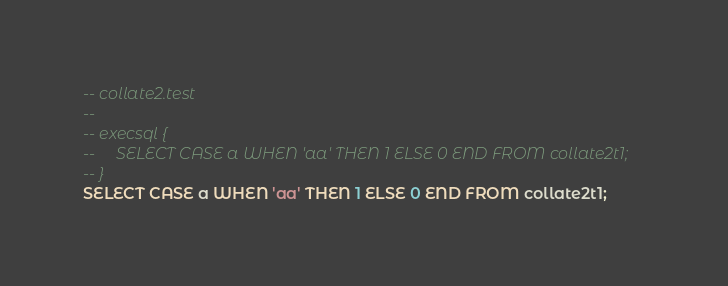Convert code to text. <code><loc_0><loc_0><loc_500><loc_500><_SQL_>-- collate2.test
-- 
-- execsql {
--     SELECT CASE a WHEN 'aa' THEN 1 ELSE 0 END FROM collate2t1;
-- }
SELECT CASE a WHEN 'aa' THEN 1 ELSE 0 END FROM collate2t1;</code> 